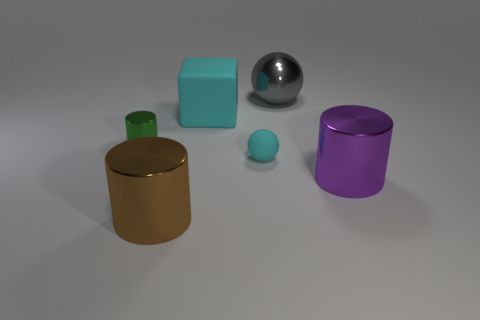Add 3 tiny purple matte cylinders. How many objects exist? 9 Subtract all balls. How many objects are left? 4 Subtract all purple cubes. Subtract all tiny green metal objects. How many objects are left? 5 Add 1 cyan objects. How many cyan objects are left? 3 Add 1 large red rubber blocks. How many large red rubber blocks exist? 1 Subtract 0 yellow cylinders. How many objects are left? 6 